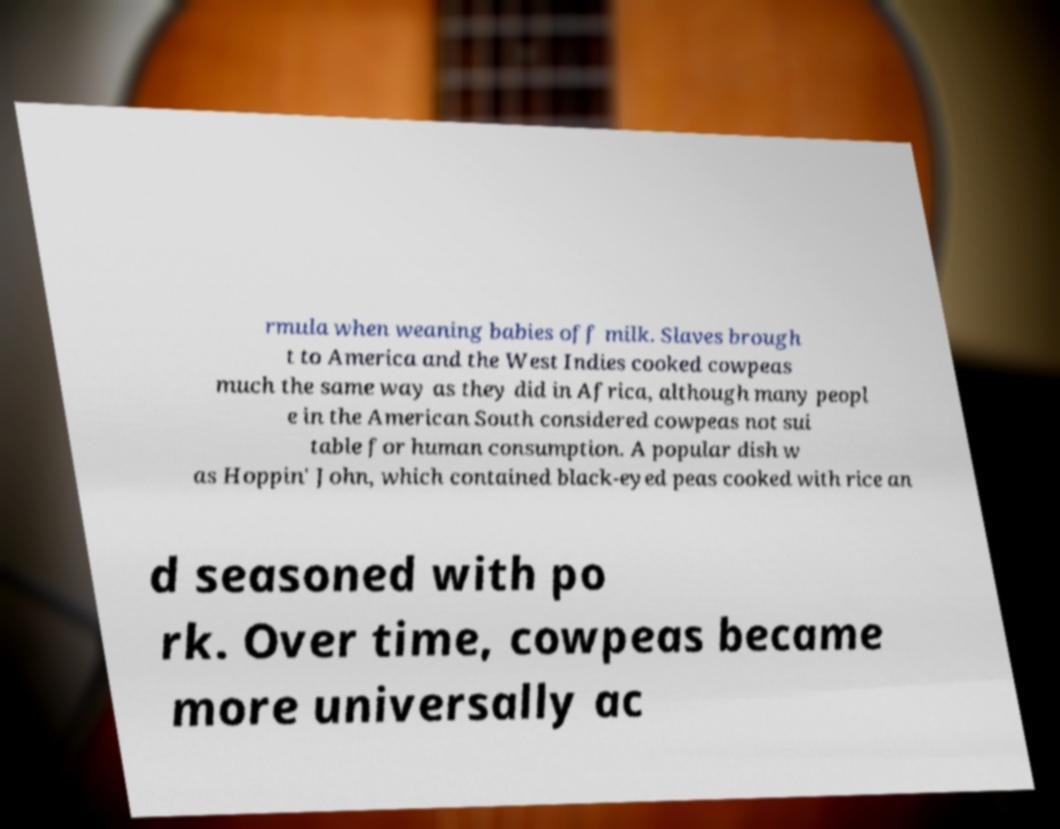Please read and relay the text visible in this image. What does it say? rmula when weaning babies off milk. Slaves brough t to America and the West Indies cooked cowpeas much the same way as they did in Africa, although many peopl e in the American South considered cowpeas not sui table for human consumption. A popular dish w as Hoppin' John, which contained black-eyed peas cooked with rice an d seasoned with po rk. Over time, cowpeas became more universally ac 